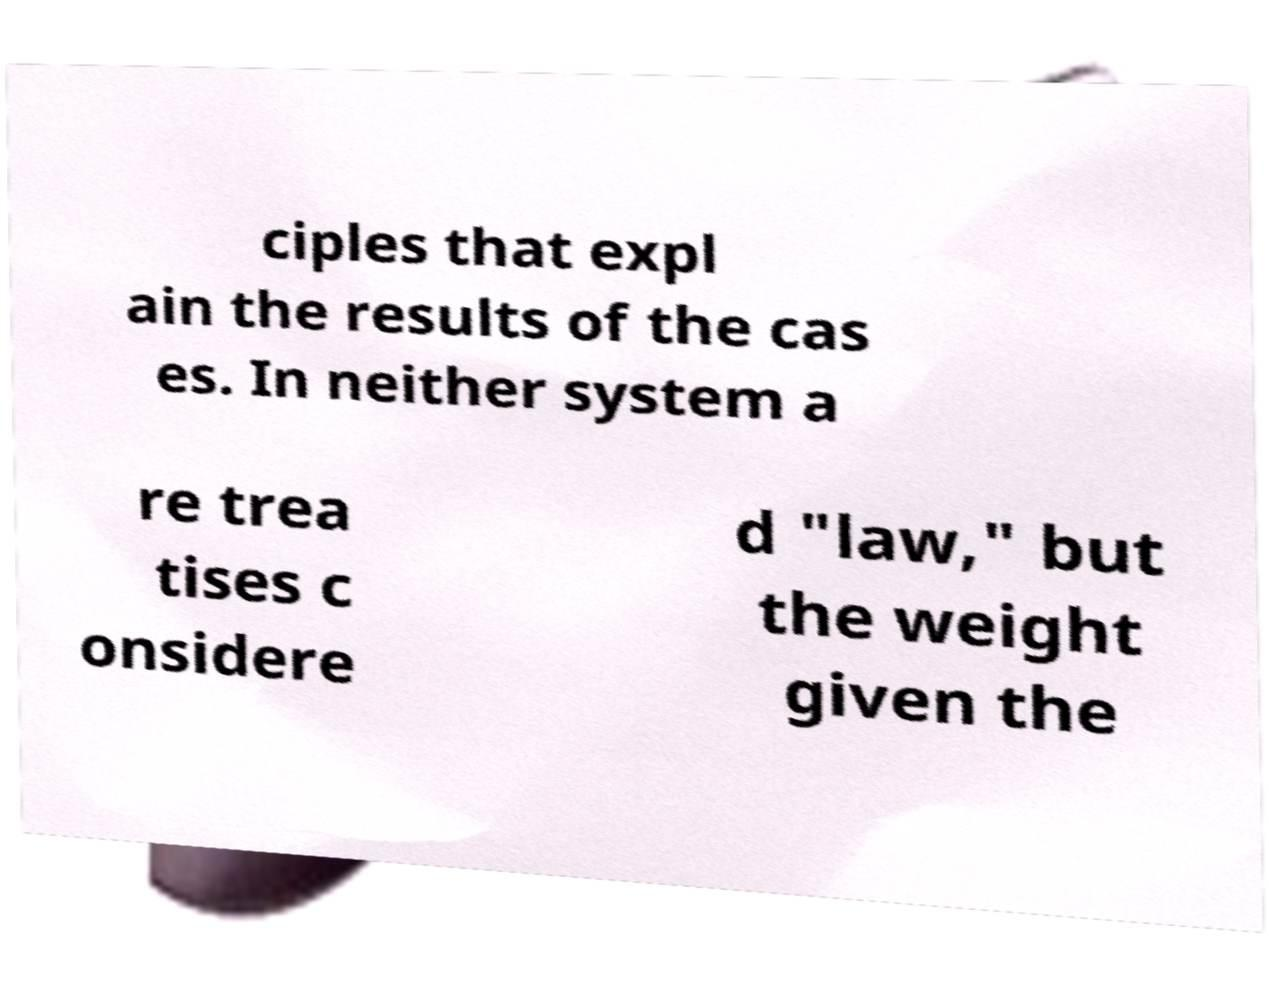What messages or text are displayed in this image? I need them in a readable, typed format. ciples that expl ain the results of the cas es. In neither system a re trea tises c onsidere d "law," but the weight given the 